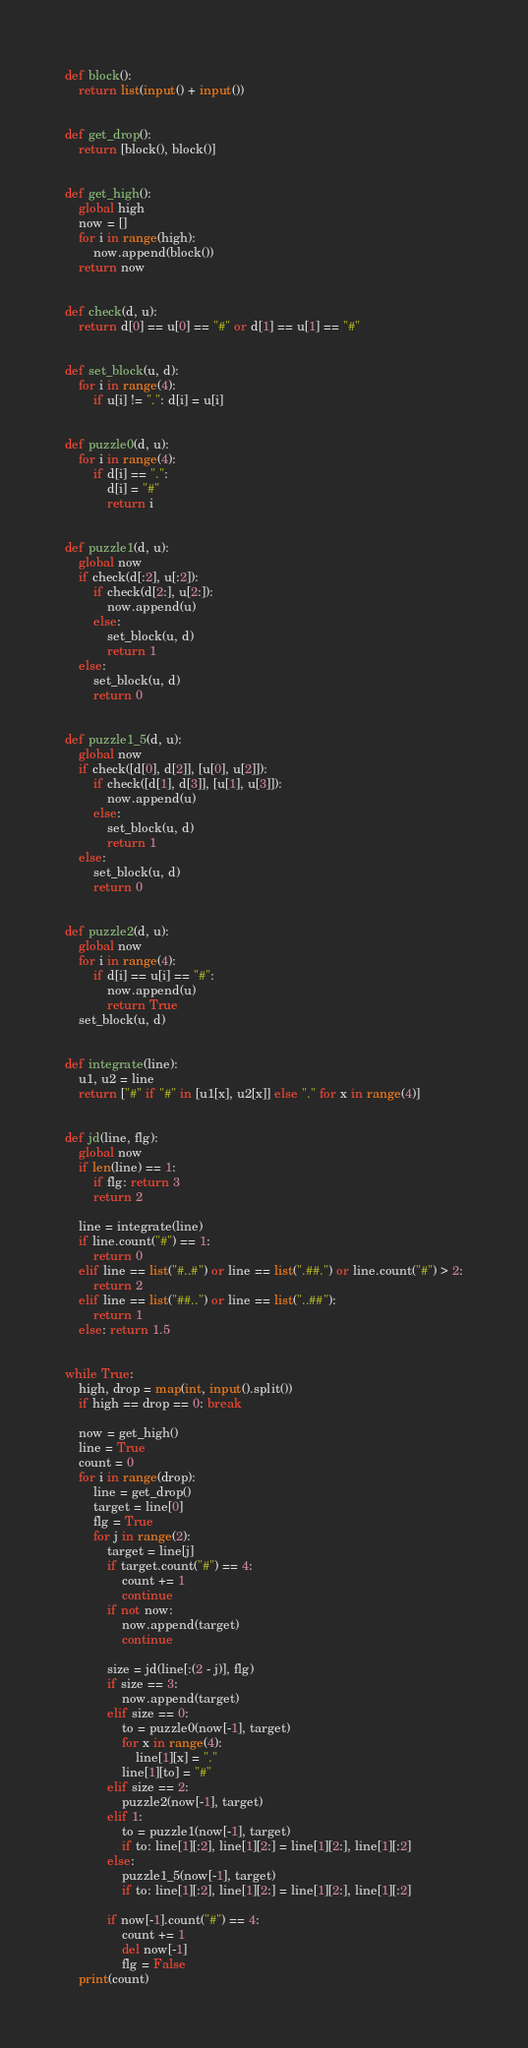Convert code to text. <code><loc_0><loc_0><loc_500><loc_500><_Python_>def block():
    return list(input() + input())


def get_drop():
    return [block(), block()]


def get_high():
    global high
    now = []
    for i in range(high):
        now.append(block())
    return now


def check(d, u):
    return d[0] == u[0] == "#" or d[1] == u[1] == "#"


def set_block(u, d):
    for i in range(4):
        if u[i] != ".": d[i] = u[i]


def puzzle0(d, u):
    for i in range(4):
        if d[i] == ".":
            d[i] = "#"
            return i


def puzzle1(d, u):
    global now
    if check(d[:2], u[:2]):
        if check(d[2:], u[2:]):
            now.append(u)
        else:
            set_block(u, d)
            return 1
    else:
        set_block(u, d)
        return 0


def puzzle1_5(d, u):
    global now
    if check([d[0], d[2]], [u[0], u[2]]):
        if check([d[1], d[3]], [u[1], u[3]]):
            now.append(u)
        else:
            set_block(u, d)
            return 1
    else:
        set_block(u, d)
        return 0


def puzzle2(d, u):
    global now
    for i in range(4):
        if d[i] == u[i] == "#":
            now.append(u)
            return True
    set_block(u, d)


def integrate(line):
    u1, u2 = line
    return ["#" if "#" in [u1[x], u2[x]] else "." for x in range(4)]


def jd(line, flg):
    global now
    if len(line) == 1:
        if flg: return 3
        return 2

    line = integrate(line)
    if line.count("#") == 1:
        return 0
    elif line == list("#..#") or line == list(".##.") or line.count("#") > 2:
        return 2
    elif line == list("##..") or line == list("..##"):
        return 1
    else: return 1.5


while True:
    high, drop = map(int, input().split())
    if high == drop == 0: break

    now = get_high()
    line = True
    count = 0
    for i in range(drop):
        line = get_drop()
        target = line[0]
        flg = True
        for j in range(2):
            target = line[j]
            if target.count("#") == 4:
                count += 1
                continue
            if not now:
                now.append(target)
                continue

            size = jd(line[:(2 - j)], flg)
            if size == 3:
                now.append(target)
            elif size == 0:
                to = puzzle0(now[-1], target)
                for x in range(4):
                    line[1][x] = "."
                line[1][to] = "#"
            elif size == 2:
                puzzle2(now[-1], target)
            elif 1:
                to = puzzle1(now[-1], target)
                if to: line[1][:2], line[1][2:] = line[1][2:], line[1][:2]
            else:
                puzzle1_5(now[-1], target)
                if to: line[1][:2], line[1][2:] = line[1][2:], line[1][:2]

            if now[-1].count("#") == 4:
                count += 1
                del now[-1]
                flg = False
    print(count)</code> 